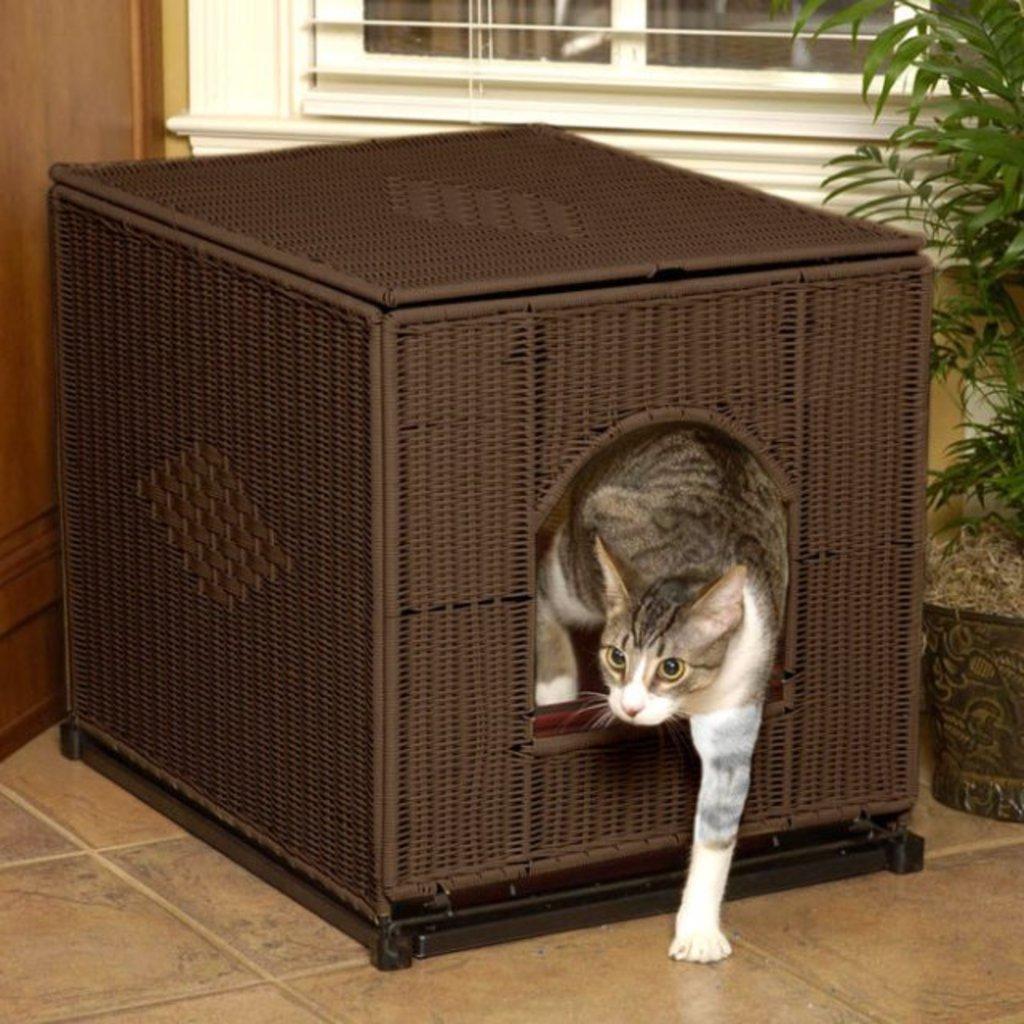Please provide a concise description of this image. In this picture there is a cat placed one of her leg outside of a brown color object and there is a plant in the right corner and there is a window in the background. 